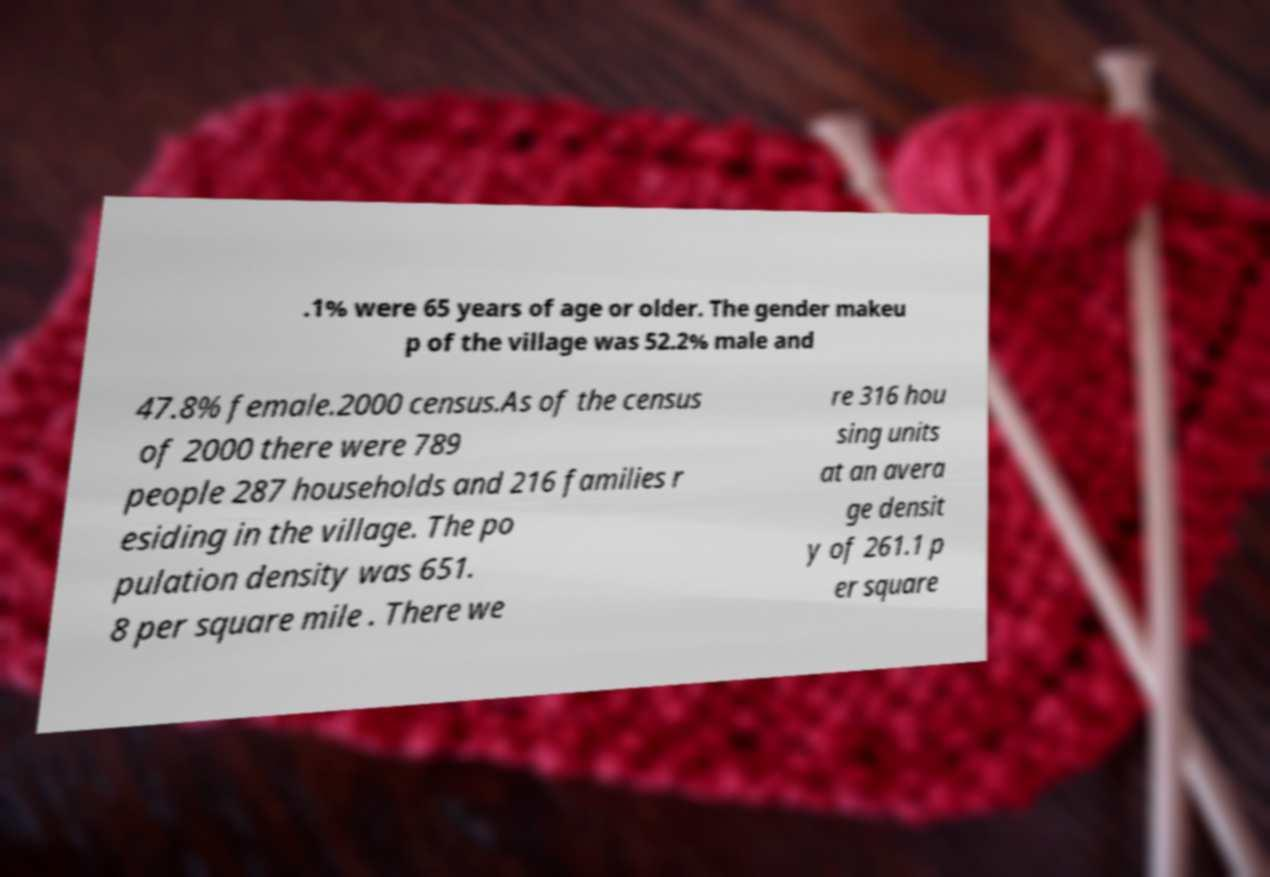Could you assist in decoding the text presented in this image and type it out clearly? .1% were 65 years of age or older. The gender makeu p of the village was 52.2% male and 47.8% female.2000 census.As of the census of 2000 there were 789 people 287 households and 216 families r esiding in the village. The po pulation density was 651. 8 per square mile . There we re 316 hou sing units at an avera ge densit y of 261.1 p er square 